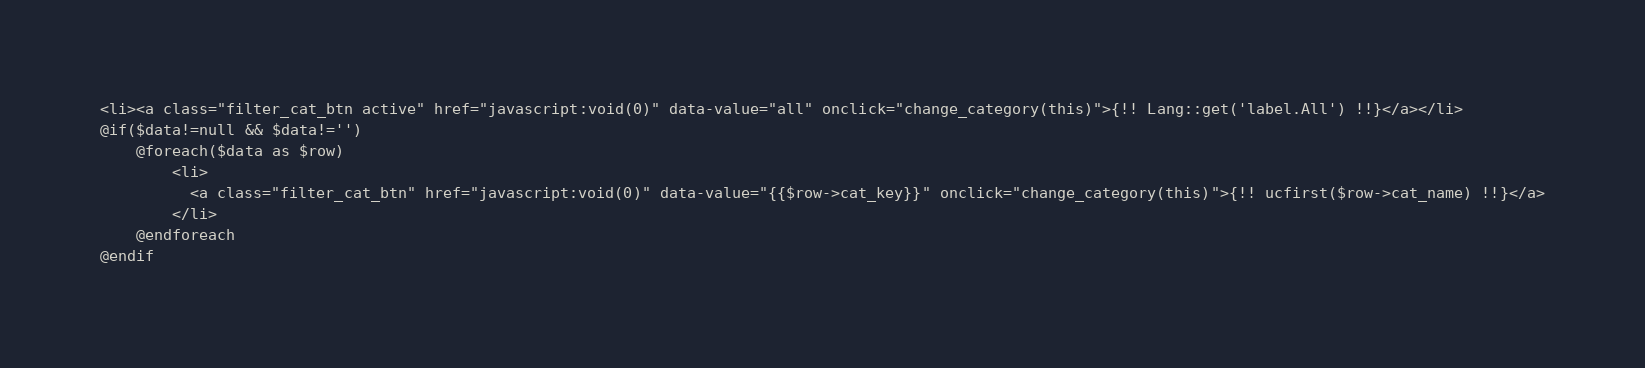<code> <loc_0><loc_0><loc_500><loc_500><_PHP_><li><a class="filter_cat_btn active" href="javascript:void(0)" data-value="all" onclick="change_category(this)">{!! Lang::get('label.All') !!}</a></li>
@if($data!=null && $data!='')
    @foreach($data as $row)
        <li>
          <a class="filter_cat_btn" href="javascript:void(0)" data-value="{{$row->cat_key}}" onclick="change_category(this)">{!! ucfirst($row->cat_name) !!}</a>
        </li>
    @endforeach
@endif</code> 